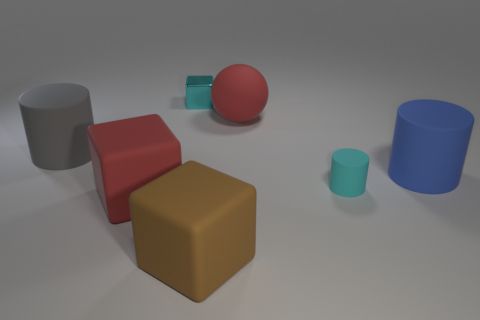Are there any other things that are made of the same material as the small cube?
Your answer should be very brief. No. Is the tiny matte cylinder the same color as the small metallic cube?
Make the answer very short. Yes. There is a big thing that is the same color as the big sphere; what is its material?
Ensure brevity in your answer.  Rubber. There is a block that is the same size as the cyan rubber cylinder; what is its material?
Your answer should be very brief. Metal. What is the shape of the cyan thing that is the same size as the cyan metal cube?
Ensure brevity in your answer.  Cylinder. What material is the block that is behind the cylinder that is left of the large red rubber object that is in front of the blue rubber cylinder?
Offer a terse response. Metal. Do the block to the left of the tiny cyan shiny object and the sphere have the same color?
Make the answer very short. Yes. What material is the thing that is to the right of the matte ball and to the left of the large blue object?
Your response must be concise. Rubber. Are there any brown rubber blocks that have the same size as the red sphere?
Ensure brevity in your answer.  Yes. What number of large gray things are there?
Your answer should be very brief. 1. 